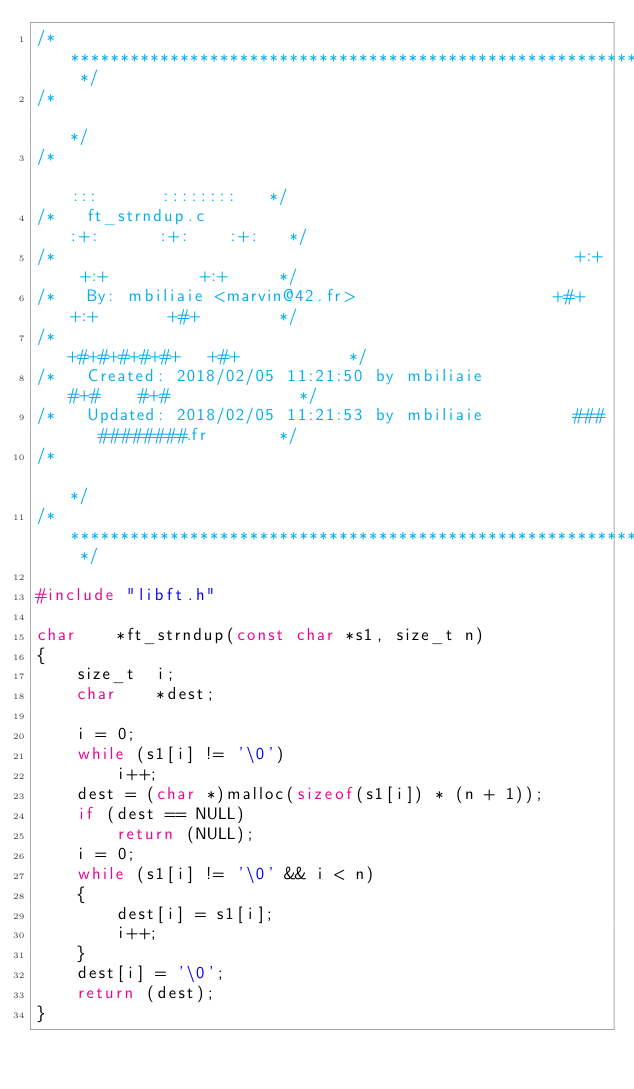<code> <loc_0><loc_0><loc_500><loc_500><_C_>/* ************************************************************************** */
/*                                                                            */
/*                                                        :::      ::::::::   */
/*   ft_strndup.c                                       :+:      :+:    :+:   */
/*                                                    +:+ +:+         +:+     */
/*   By: mbiliaie <marvin@42.fr>                    +#+  +:+       +#+        */
/*                                                +#+#+#+#+#+   +#+           */
/*   Created: 2018/02/05 11:21:50 by mbiliaie          #+#    #+#             */
/*   Updated: 2018/02/05 11:21:53 by mbiliaie         ###   ########.fr       */
/*                                                                            */
/* ************************************************************************** */

#include "libft.h"

char	*ft_strndup(const char *s1, size_t n)
{
	size_t	i;
	char	*dest;

	i = 0;
	while (s1[i] != '\0')
		i++;
	dest = (char *)malloc(sizeof(s1[i]) * (n + 1));
	if (dest == NULL)
		return (NULL);
	i = 0;
	while (s1[i] != '\0' && i < n)
	{
		dest[i] = s1[i];
		i++;
	}
	dest[i] = '\0';
	return (dest);
}
</code> 